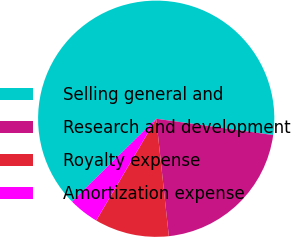Convert chart to OTSL. <chart><loc_0><loc_0><loc_500><loc_500><pie_chart><fcel>Selling general and<fcel>Research and development<fcel>Royalty expense<fcel>Amortization expense<nl><fcel>64.57%<fcel>21.09%<fcel>10.19%<fcel>4.15%<nl></chart> 